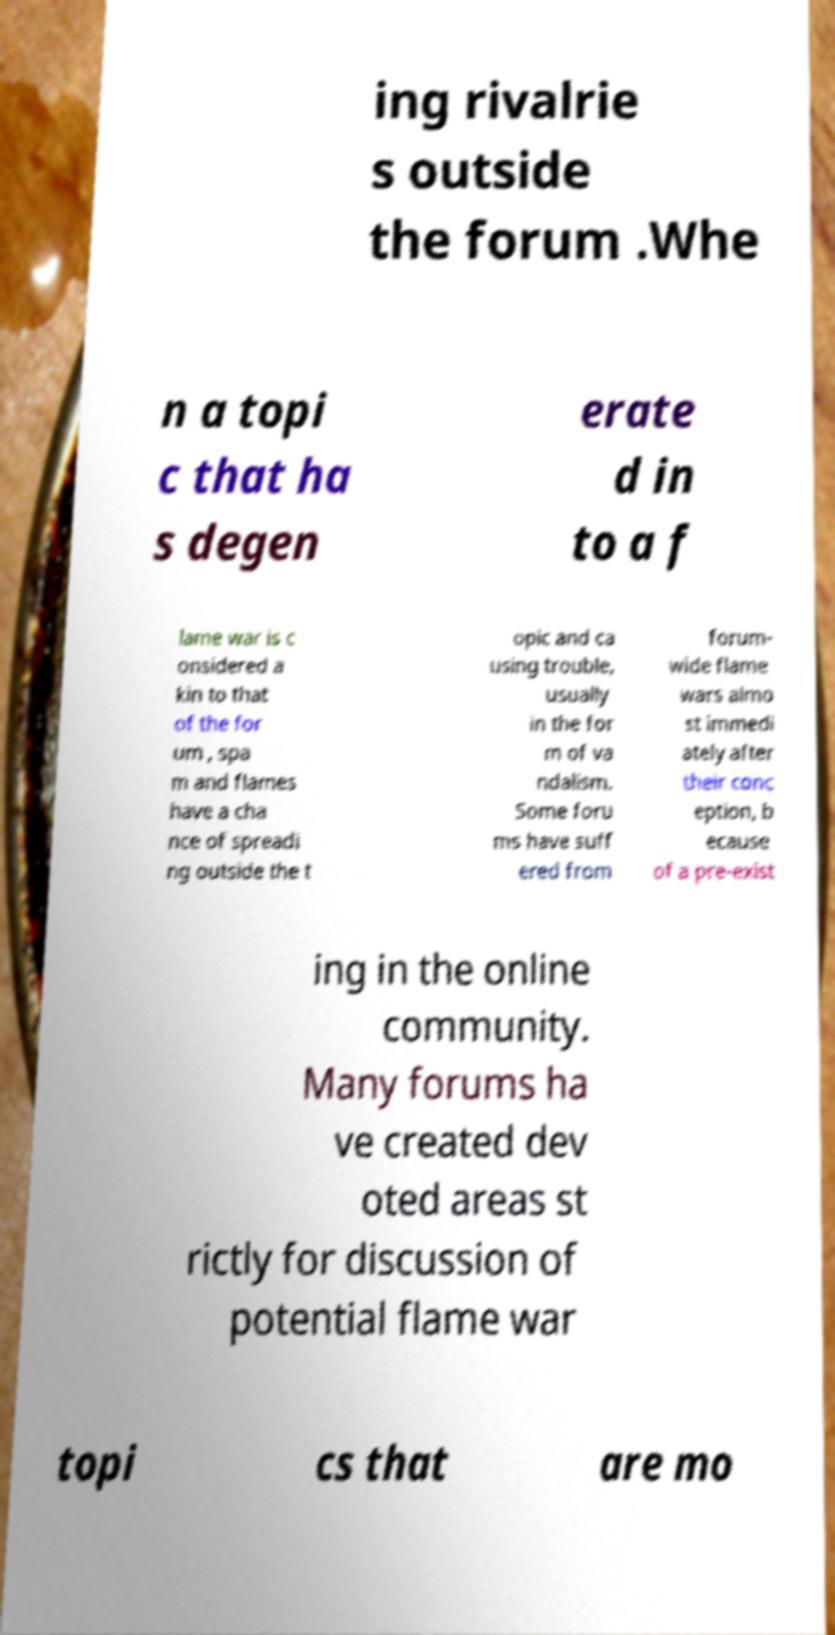What messages or text are displayed in this image? I need them in a readable, typed format. ing rivalrie s outside the forum .Whe n a topi c that ha s degen erate d in to a f lame war is c onsidered a kin to that of the for um , spa m and flames have a cha nce of spreadi ng outside the t opic and ca using trouble, usually in the for m of va ndalism. Some foru ms have suff ered from forum- wide flame wars almo st immedi ately after their conc eption, b ecause of a pre-exist ing in the online community. Many forums ha ve created dev oted areas st rictly for discussion of potential flame war topi cs that are mo 